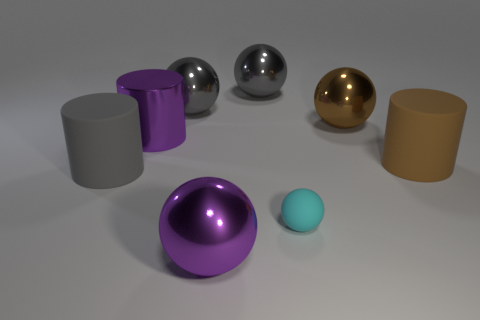Subtract all brown balls. How many balls are left? 4 Subtract all purple spheres. How many spheres are left? 4 Subtract all green balls. Subtract all yellow blocks. How many balls are left? 5 Add 2 small shiny objects. How many objects exist? 10 Subtract all balls. How many objects are left? 3 Subtract all tiny gray metal spheres. Subtract all tiny matte objects. How many objects are left? 7 Add 3 small rubber spheres. How many small rubber spheres are left? 4 Add 2 small objects. How many small objects exist? 3 Subtract 0 red balls. How many objects are left? 8 